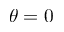<formula> <loc_0><loc_0><loc_500><loc_500>\theta = 0</formula> 